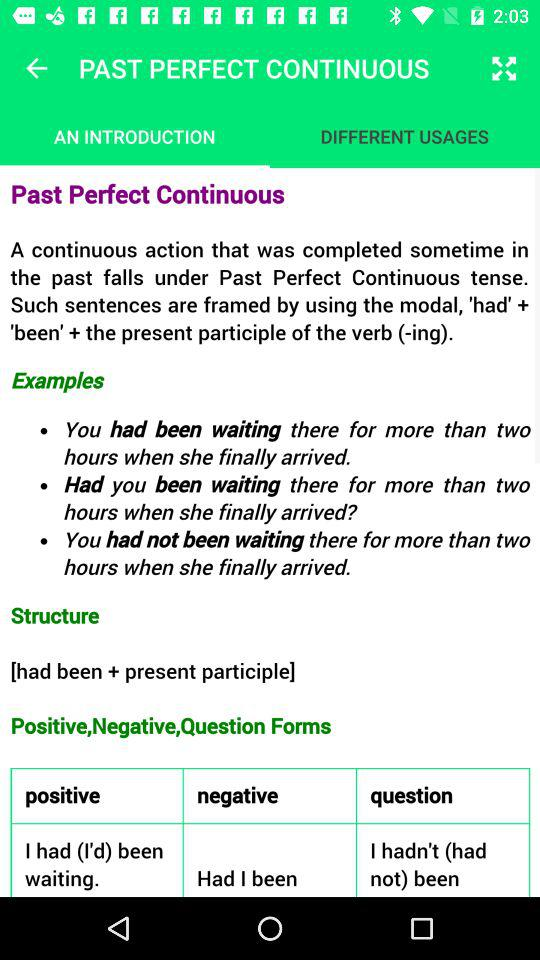How many examples are there in the examples section?
Answer the question using a single word or phrase. 3 